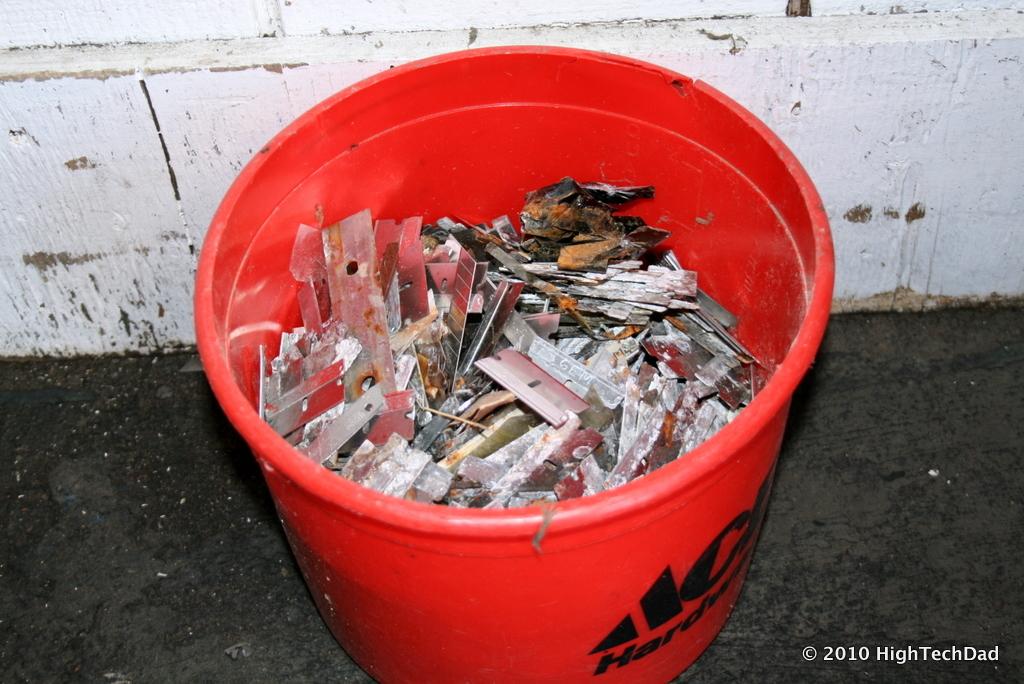What company did this bucket come from?
Ensure brevity in your answer.  Ace hardware. 